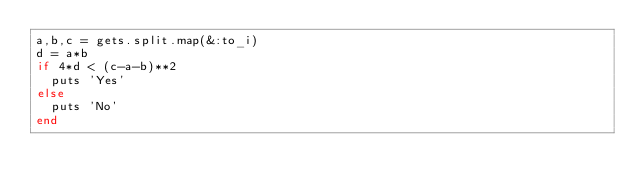Convert code to text. <code><loc_0><loc_0><loc_500><loc_500><_Ruby_>a,b,c = gets.split.map(&:to_i)
d = a*b
if 4*d < (c-a-b)**2
  puts 'Yes'
else
  puts 'No'
end</code> 